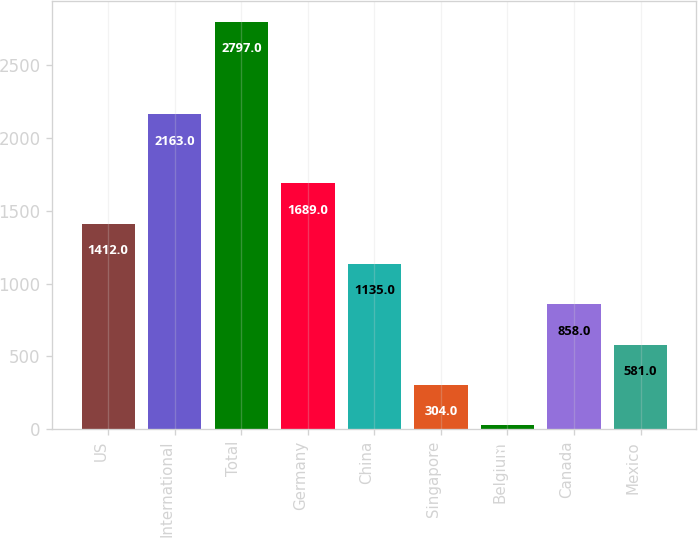Convert chart to OTSL. <chart><loc_0><loc_0><loc_500><loc_500><bar_chart><fcel>US<fcel>International<fcel>Total<fcel>Germany<fcel>China<fcel>Singapore<fcel>Belgium<fcel>Canada<fcel>Mexico<nl><fcel>1412<fcel>2163<fcel>2797<fcel>1689<fcel>1135<fcel>304<fcel>27<fcel>858<fcel>581<nl></chart> 